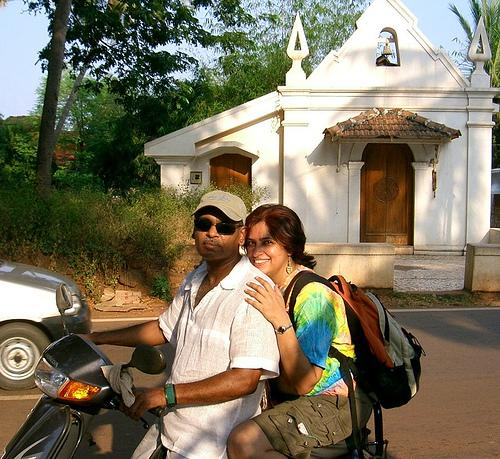What season is most likely?

Choices:
A) spring
B) summer
C) autumn
D) winter summer 